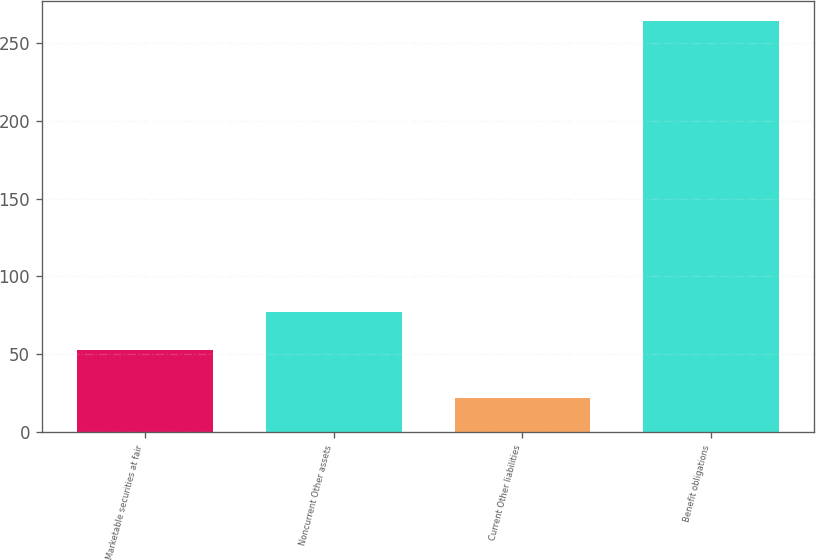Convert chart. <chart><loc_0><loc_0><loc_500><loc_500><bar_chart><fcel>Marketable securities at fair<fcel>Noncurrent Other assets<fcel>Current Other liabilities<fcel>Benefit obligations<nl><fcel>53<fcel>77.2<fcel>22<fcel>264<nl></chart> 